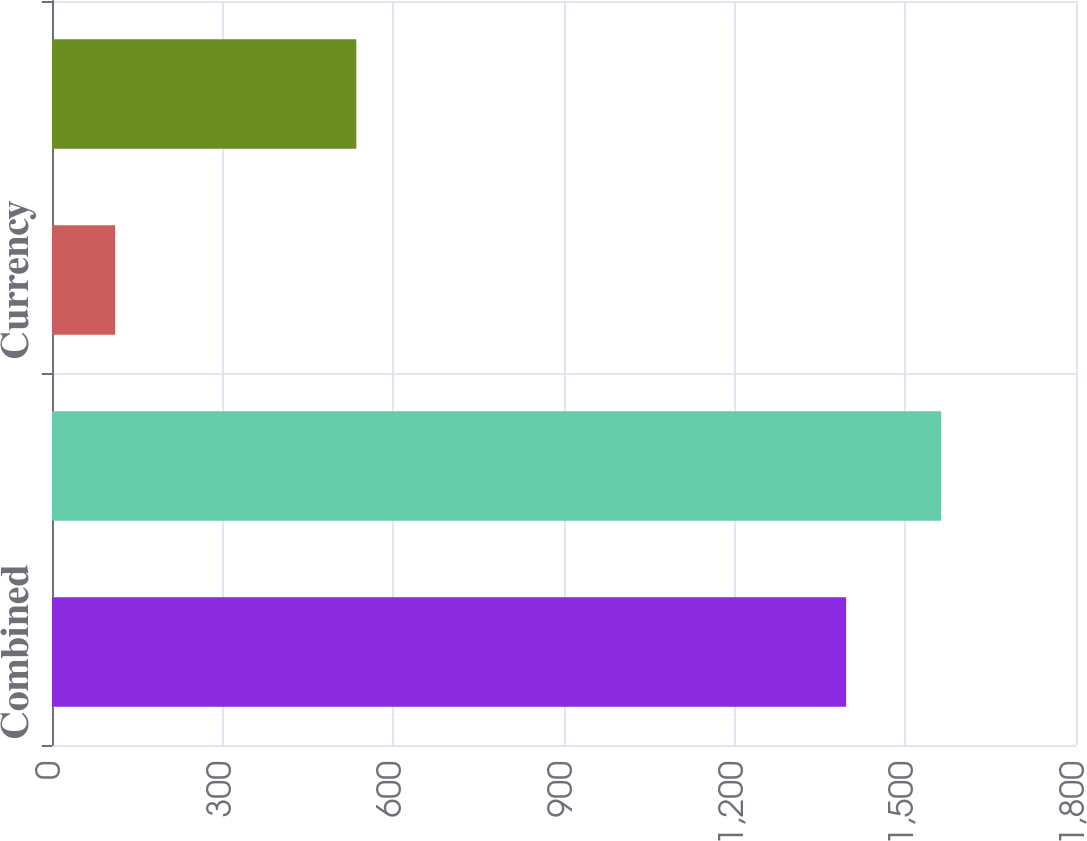Convert chart. <chart><loc_0><loc_0><loc_500><loc_500><bar_chart><fcel>Combined<fcel>Interest rate<fcel>Currency<fcel>Equity<nl><fcel>1396<fcel>1563<fcel>111<fcel>535<nl></chart> 